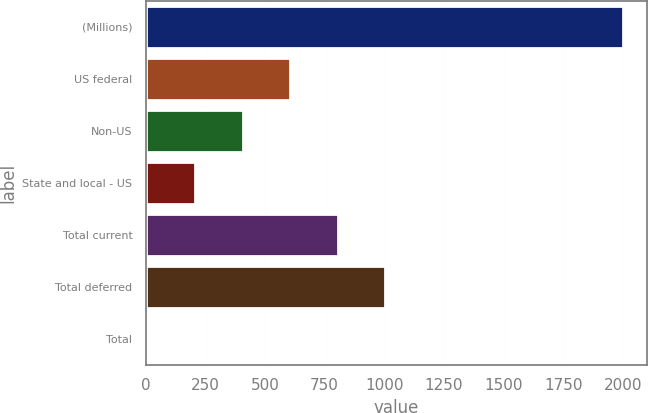<chart> <loc_0><loc_0><loc_500><loc_500><bar_chart><fcel>(Millions)<fcel>US federal<fcel>Non-US<fcel>State and local - US<fcel>Total current<fcel>Total deferred<fcel>Total<nl><fcel>2002<fcel>605.5<fcel>406<fcel>206.5<fcel>805<fcel>1004.5<fcel>7<nl></chart> 